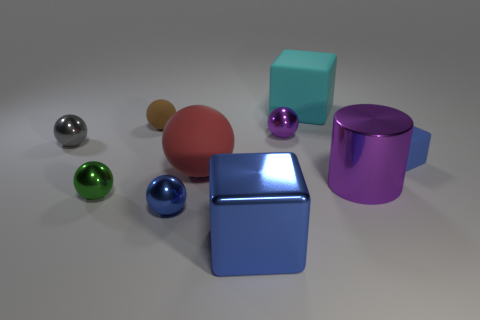There is a metallic ball that is on the right side of the big red thing; how many small blue rubber cubes are behind it?
Give a very brief answer. 0. Is the size of the gray object the same as the red matte ball?
Provide a succinct answer. No. How many green balls are made of the same material as the tiny gray thing?
Make the answer very short. 1. The purple object that is the same shape as the large red thing is what size?
Provide a succinct answer. Small. Does the large shiny object that is in front of the metallic cylinder have the same shape as the large red object?
Make the answer very short. No. The blue object on the left side of the cube in front of the blue sphere is what shape?
Your answer should be very brief. Sphere. Are there any other things that are the same shape as the small blue metal object?
Offer a terse response. Yes. What color is the large rubber object that is the same shape as the green shiny thing?
Provide a short and direct response. Red. There is a big cylinder; is it the same color as the large block that is in front of the big matte ball?
Ensure brevity in your answer.  No. What is the shape of the large object that is both on the left side of the cyan rubber thing and behind the blue metal cube?
Offer a terse response. Sphere. 